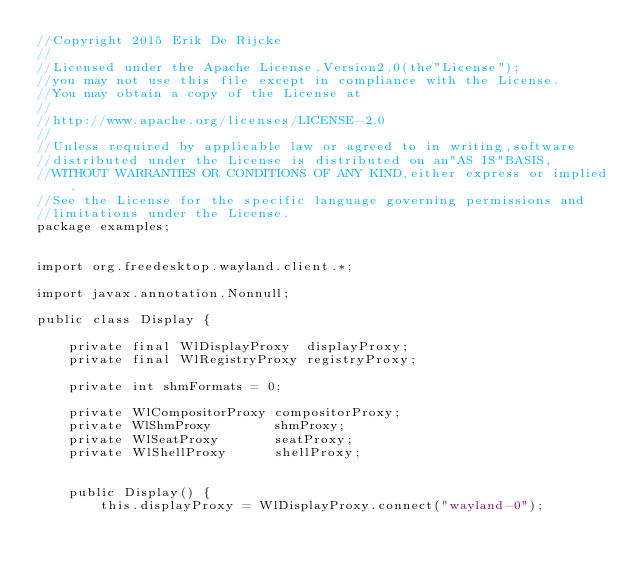<code> <loc_0><loc_0><loc_500><loc_500><_Java_>//Copyright 2015 Erik De Rijcke
//
//Licensed under the Apache License,Version2.0(the"License");
//you may not use this file except in compliance with the License.
//You may obtain a copy of the License at
//
//http://www.apache.org/licenses/LICENSE-2.0
//
//Unless required by applicable law or agreed to in writing,software
//distributed under the License is distributed on an"AS IS"BASIS,
//WITHOUT WARRANTIES OR CONDITIONS OF ANY KIND,either express or implied.
//See the License for the specific language governing permissions and
//limitations under the License.
package examples;


import org.freedesktop.wayland.client.*;

import javax.annotation.Nonnull;

public class Display {

    private final WlDisplayProxy  displayProxy;
    private final WlRegistryProxy registryProxy;

    private int shmFormats = 0;

    private WlCompositorProxy compositorProxy;
    private WlShmProxy        shmProxy;
    private WlSeatProxy       seatProxy;
    private WlShellProxy      shellProxy;


    public Display() {
        this.displayProxy = WlDisplayProxy.connect("wayland-0");</code> 